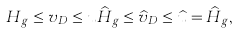Convert formula to latex. <formula><loc_0><loc_0><loc_500><loc_500>H _ { g } \leq v _ { D } \leq u \widehat { H } _ { g } \leq \widehat { v } _ { D } \leq \widehat { u } = \widehat { H } _ { g } ,</formula> 